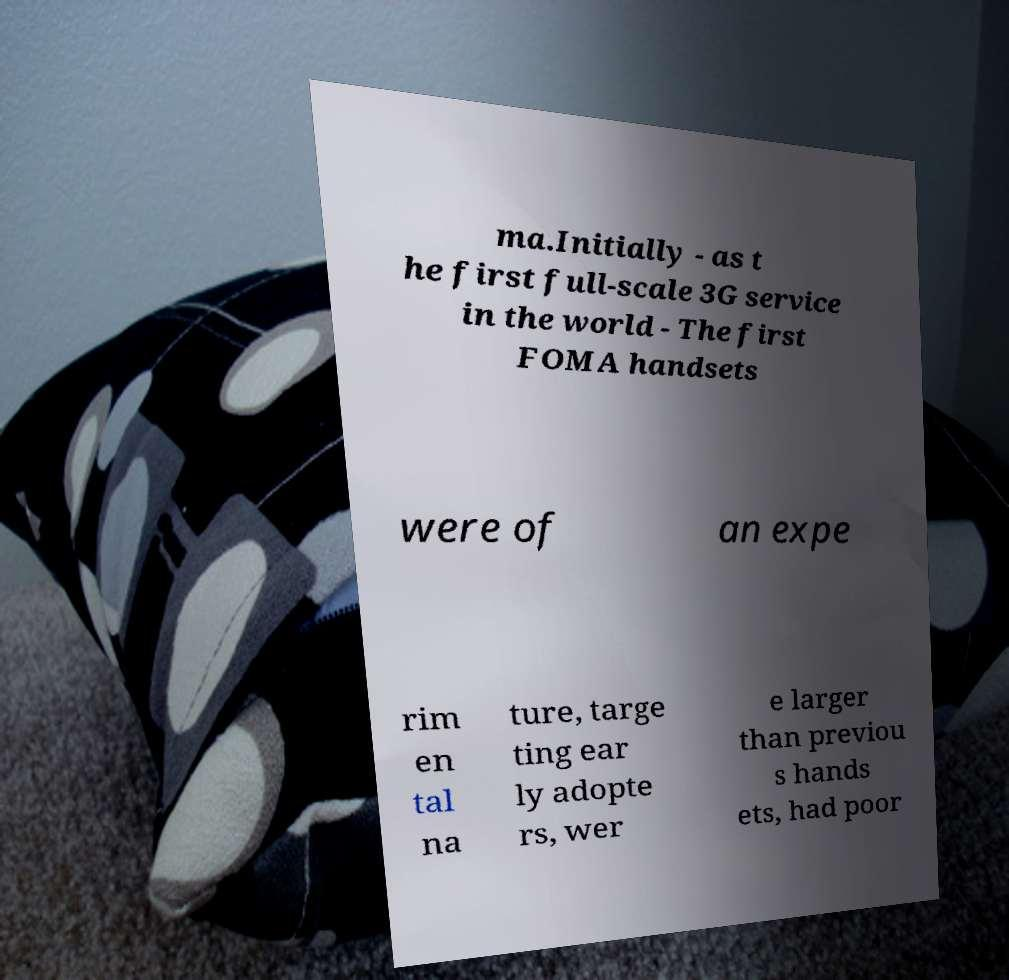For documentation purposes, I need the text within this image transcribed. Could you provide that? ma.Initially - as t he first full-scale 3G service in the world - The first FOMA handsets were of an expe rim en tal na ture, targe ting ear ly adopte rs, wer e larger than previou s hands ets, had poor 